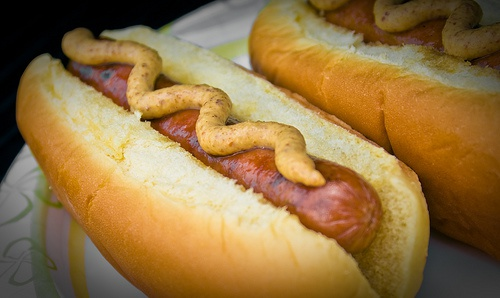Describe the objects in this image and their specific colors. I can see a hot dog in black, olive, tan, and maroon tones in this image. 